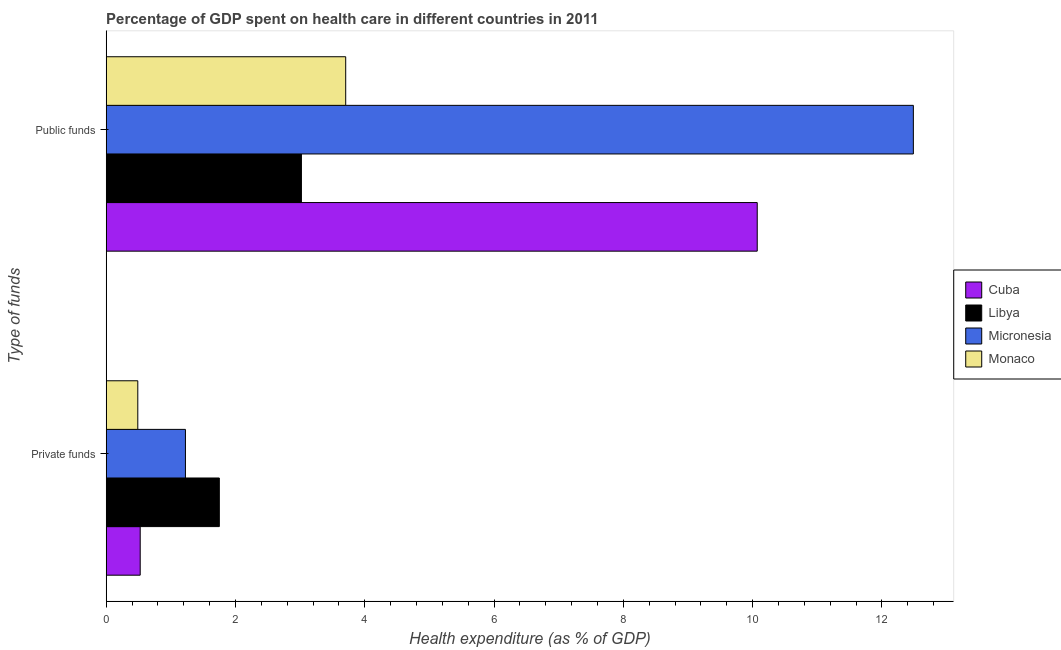How many different coloured bars are there?
Your answer should be compact. 4. How many groups of bars are there?
Provide a short and direct response. 2. Are the number of bars on each tick of the Y-axis equal?
Provide a succinct answer. Yes. How many bars are there on the 1st tick from the bottom?
Your answer should be compact. 4. What is the label of the 1st group of bars from the top?
Give a very brief answer. Public funds. What is the amount of private funds spent in healthcare in Cuba?
Your response must be concise. 0.53. Across all countries, what is the maximum amount of private funds spent in healthcare?
Your response must be concise. 1.75. Across all countries, what is the minimum amount of private funds spent in healthcare?
Offer a very short reply. 0.49. In which country was the amount of public funds spent in healthcare maximum?
Give a very brief answer. Micronesia. In which country was the amount of public funds spent in healthcare minimum?
Offer a terse response. Libya. What is the total amount of public funds spent in healthcare in the graph?
Your answer should be very brief. 29.28. What is the difference between the amount of public funds spent in healthcare in Micronesia and that in Libya?
Provide a succinct answer. 9.47. What is the difference between the amount of private funds spent in healthcare in Monaco and the amount of public funds spent in healthcare in Cuba?
Your response must be concise. -9.58. What is the average amount of public funds spent in healthcare per country?
Provide a short and direct response. 7.32. What is the difference between the amount of private funds spent in healthcare and amount of public funds spent in healthcare in Micronesia?
Offer a very short reply. -11.26. What is the ratio of the amount of private funds spent in healthcare in Micronesia to that in Cuba?
Offer a very short reply. 2.33. In how many countries, is the amount of public funds spent in healthcare greater than the average amount of public funds spent in healthcare taken over all countries?
Offer a terse response. 2. What does the 3rd bar from the top in Private funds represents?
Provide a succinct answer. Libya. What does the 2nd bar from the bottom in Public funds represents?
Offer a very short reply. Libya. What is the title of the graph?
Offer a terse response. Percentage of GDP spent on health care in different countries in 2011. What is the label or title of the X-axis?
Make the answer very short. Health expenditure (as % of GDP). What is the label or title of the Y-axis?
Your response must be concise. Type of funds. What is the Health expenditure (as % of GDP) of Cuba in Private funds?
Ensure brevity in your answer.  0.53. What is the Health expenditure (as % of GDP) of Libya in Private funds?
Your answer should be compact. 1.75. What is the Health expenditure (as % of GDP) of Micronesia in Private funds?
Give a very brief answer. 1.23. What is the Health expenditure (as % of GDP) of Monaco in Private funds?
Your answer should be compact. 0.49. What is the Health expenditure (as % of GDP) of Cuba in Public funds?
Give a very brief answer. 10.07. What is the Health expenditure (as % of GDP) of Libya in Public funds?
Your answer should be very brief. 3.02. What is the Health expenditure (as % of GDP) in Micronesia in Public funds?
Your answer should be compact. 12.49. What is the Health expenditure (as % of GDP) in Monaco in Public funds?
Your answer should be very brief. 3.7. Across all Type of funds, what is the maximum Health expenditure (as % of GDP) of Cuba?
Your answer should be very brief. 10.07. Across all Type of funds, what is the maximum Health expenditure (as % of GDP) in Libya?
Make the answer very short. 3.02. Across all Type of funds, what is the maximum Health expenditure (as % of GDP) in Micronesia?
Offer a terse response. 12.49. Across all Type of funds, what is the maximum Health expenditure (as % of GDP) in Monaco?
Your answer should be compact. 3.7. Across all Type of funds, what is the minimum Health expenditure (as % of GDP) in Cuba?
Provide a succinct answer. 0.53. Across all Type of funds, what is the minimum Health expenditure (as % of GDP) in Libya?
Offer a terse response. 1.75. Across all Type of funds, what is the minimum Health expenditure (as % of GDP) in Micronesia?
Offer a terse response. 1.23. Across all Type of funds, what is the minimum Health expenditure (as % of GDP) in Monaco?
Your answer should be compact. 0.49. What is the total Health expenditure (as % of GDP) in Cuba in the graph?
Keep it short and to the point. 10.6. What is the total Health expenditure (as % of GDP) of Libya in the graph?
Give a very brief answer. 4.77. What is the total Health expenditure (as % of GDP) in Micronesia in the graph?
Make the answer very short. 13.71. What is the total Health expenditure (as % of GDP) in Monaco in the graph?
Your answer should be compact. 4.19. What is the difference between the Health expenditure (as % of GDP) in Cuba in Private funds and that in Public funds?
Provide a short and direct response. -9.55. What is the difference between the Health expenditure (as % of GDP) in Libya in Private funds and that in Public funds?
Ensure brevity in your answer.  -1.27. What is the difference between the Health expenditure (as % of GDP) of Micronesia in Private funds and that in Public funds?
Your answer should be very brief. -11.26. What is the difference between the Health expenditure (as % of GDP) of Monaco in Private funds and that in Public funds?
Provide a short and direct response. -3.22. What is the difference between the Health expenditure (as % of GDP) in Cuba in Private funds and the Health expenditure (as % of GDP) in Libya in Public funds?
Offer a very short reply. -2.49. What is the difference between the Health expenditure (as % of GDP) of Cuba in Private funds and the Health expenditure (as % of GDP) of Micronesia in Public funds?
Ensure brevity in your answer.  -11.96. What is the difference between the Health expenditure (as % of GDP) in Cuba in Private funds and the Health expenditure (as % of GDP) in Monaco in Public funds?
Your answer should be very brief. -3.18. What is the difference between the Health expenditure (as % of GDP) of Libya in Private funds and the Health expenditure (as % of GDP) of Micronesia in Public funds?
Provide a succinct answer. -10.74. What is the difference between the Health expenditure (as % of GDP) of Libya in Private funds and the Health expenditure (as % of GDP) of Monaco in Public funds?
Give a very brief answer. -1.96. What is the difference between the Health expenditure (as % of GDP) of Micronesia in Private funds and the Health expenditure (as % of GDP) of Monaco in Public funds?
Offer a very short reply. -2.48. What is the average Health expenditure (as % of GDP) in Cuba per Type of funds?
Your response must be concise. 5.3. What is the average Health expenditure (as % of GDP) of Libya per Type of funds?
Your answer should be compact. 2.38. What is the average Health expenditure (as % of GDP) in Micronesia per Type of funds?
Make the answer very short. 6.86. What is the average Health expenditure (as % of GDP) in Monaco per Type of funds?
Offer a very short reply. 2.1. What is the difference between the Health expenditure (as % of GDP) of Cuba and Health expenditure (as % of GDP) of Libya in Private funds?
Provide a short and direct response. -1.22. What is the difference between the Health expenditure (as % of GDP) of Cuba and Health expenditure (as % of GDP) of Micronesia in Private funds?
Make the answer very short. -0.7. What is the difference between the Health expenditure (as % of GDP) of Cuba and Health expenditure (as % of GDP) of Monaco in Private funds?
Provide a succinct answer. 0.04. What is the difference between the Health expenditure (as % of GDP) in Libya and Health expenditure (as % of GDP) in Micronesia in Private funds?
Your response must be concise. 0.52. What is the difference between the Health expenditure (as % of GDP) of Libya and Health expenditure (as % of GDP) of Monaco in Private funds?
Offer a very short reply. 1.26. What is the difference between the Health expenditure (as % of GDP) in Micronesia and Health expenditure (as % of GDP) in Monaco in Private funds?
Make the answer very short. 0.74. What is the difference between the Health expenditure (as % of GDP) of Cuba and Health expenditure (as % of GDP) of Libya in Public funds?
Your response must be concise. 7.05. What is the difference between the Health expenditure (as % of GDP) in Cuba and Health expenditure (as % of GDP) in Micronesia in Public funds?
Your response must be concise. -2.42. What is the difference between the Health expenditure (as % of GDP) in Cuba and Health expenditure (as % of GDP) in Monaco in Public funds?
Your answer should be compact. 6.37. What is the difference between the Health expenditure (as % of GDP) in Libya and Health expenditure (as % of GDP) in Micronesia in Public funds?
Give a very brief answer. -9.47. What is the difference between the Health expenditure (as % of GDP) of Libya and Health expenditure (as % of GDP) of Monaco in Public funds?
Give a very brief answer. -0.69. What is the difference between the Health expenditure (as % of GDP) of Micronesia and Health expenditure (as % of GDP) of Monaco in Public funds?
Your response must be concise. 8.78. What is the ratio of the Health expenditure (as % of GDP) in Cuba in Private funds to that in Public funds?
Make the answer very short. 0.05. What is the ratio of the Health expenditure (as % of GDP) of Libya in Private funds to that in Public funds?
Offer a very short reply. 0.58. What is the ratio of the Health expenditure (as % of GDP) of Micronesia in Private funds to that in Public funds?
Your response must be concise. 0.1. What is the ratio of the Health expenditure (as % of GDP) in Monaco in Private funds to that in Public funds?
Offer a very short reply. 0.13. What is the difference between the highest and the second highest Health expenditure (as % of GDP) in Cuba?
Your response must be concise. 9.55. What is the difference between the highest and the second highest Health expenditure (as % of GDP) in Libya?
Make the answer very short. 1.27. What is the difference between the highest and the second highest Health expenditure (as % of GDP) in Micronesia?
Your answer should be compact. 11.26. What is the difference between the highest and the second highest Health expenditure (as % of GDP) of Monaco?
Your response must be concise. 3.22. What is the difference between the highest and the lowest Health expenditure (as % of GDP) in Cuba?
Give a very brief answer. 9.55. What is the difference between the highest and the lowest Health expenditure (as % of GDP) in Libya?
Make the answer very short. 1.27. What is the difference between the highest and the lowest Health expenditure (as % of GDP) in Micronesia?
Offer a very short reply. 11.26. What is the difference between the highest and the lowest Health expenditure (as % of GDP) of Monaco?
Your response must be concise. 3.22. 